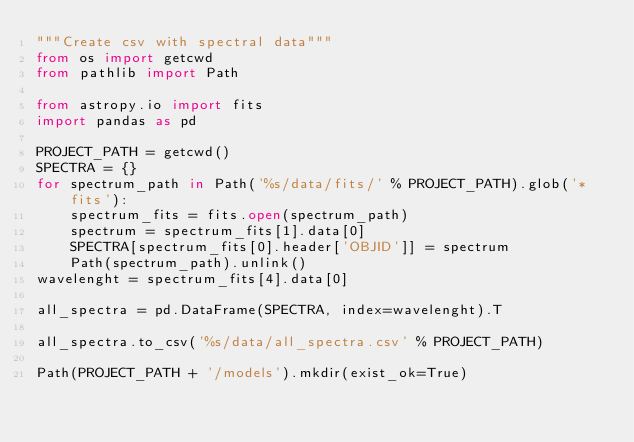<code> <loc_0><loc_0><loc_500><loc_500><_Python_>"""Create csv with spectral data"""
from os import getcwd
from pathlib import Path

from astropy.io import fits
import pandas as pd

PROJECT_PATH = getcwd()
SPECTRA = {}
for spectrum_path in Path('%s/data/fits/' % PROJECT_PATH).glob('*fits'):
    spectrum_fits = fits.open(spectrum_path)
    spectrum = spectrum_fits[1].data[0]
    SPECTRA[spectrum_fits[0].header['OBJID']] = spectrum
    Path(spectrum_path).unlink()
wavelenght = spectrum_fits[4].data[0]

all_spectra = pd.DataFrame(SPECTRA, index=wavelenght).T

all_spectra.to_csv('%s/data/all_spectra.csv' % PROJECT_PATH)

Path(PROJECT_PATH + '/models').mkdir(exist_ok=True)
</code> 